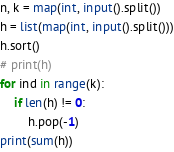<code> <loc_0><loc_0><loc_500><loc_500><_Python_>n, k = map(int, input().split())
h = list(map(int, input().split()))
h.sort()
# print(h)
for ind in range(k):
    if len(h) != 0:
        h.pop(-1)   
print(sum(h))
</code> 